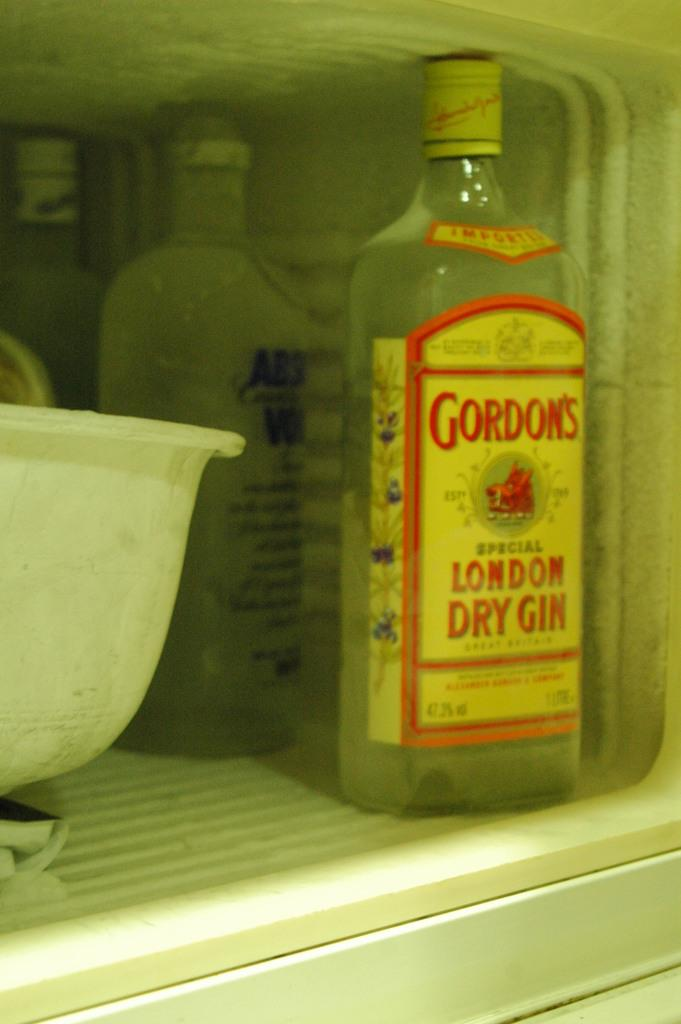What is the main object in the image? There is a wine bottle in the image. Where is the wine bottle located? The wine bottle is kept in a refrigerator. What is the name of the person who believes in the treatment mentioned in the image? There is no person or treatment mentioned in the image, as it only features a wine bottle in a refrigerator. 